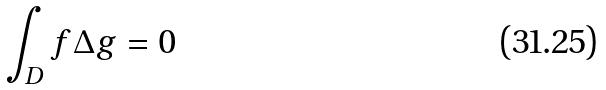<formula> <loc_0><loc_0><loc_500><loc_500>\int _ { D } f \Delta g = 0</formula> 